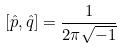<formula> <loc_0><loc_0><loc_500><loc_500>[ \hat { p } , \hat { q } ] = \frac { 1 } { 2 \pi \sqrt { - 1 } }</formula> 